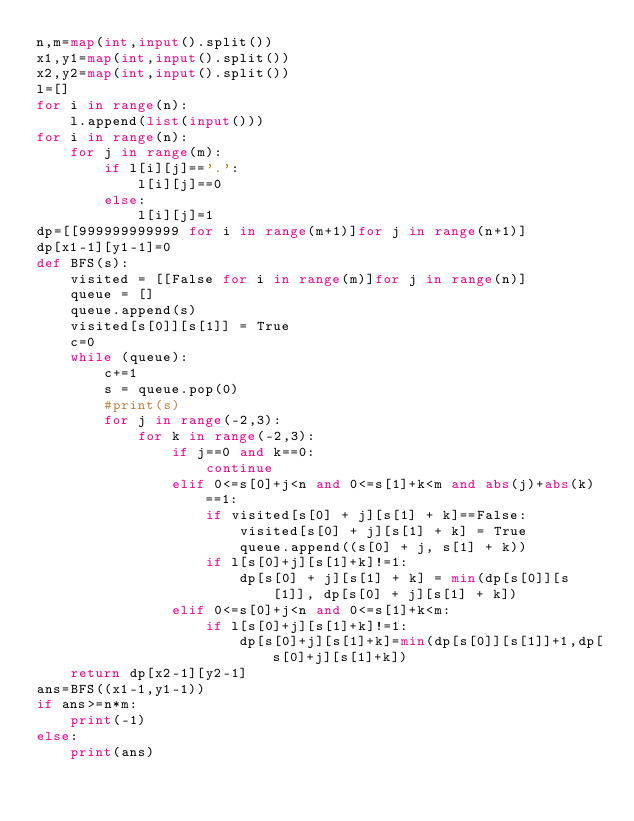Convert code to text. <code><loc_0><loc_0><loc_500><loc_500><_Python_>n,m=map(int,input().split())
x1,y1=map(int,input().split())
x2,y2=map(int,input().split())
l=[]
for i in range(n):
    l.append(list(input()))
for i in range(n):
    for j in range(m):
        if l[i][j]=='.':
            l[i][j]==0
        else:
            l[i][j]=1
dp=[[999999999999 for i in range(m+1)]for j in range(n+1)]
dp[x1-1][y1-1]=0
def BFS(s):
    visited = [[False for i in range(m)]for j in range(n)]
    queue = []
    queue.append(s)
    visited[s[0]][s[1]] = True
    c=0
    while (queue):
        c+=1
        s = queue.pop(0)
        #print(s)
        for j in range(-2,3):
            for k in range(-2,3):
                if j==0 and k==0:
                    continue
                elif 0<=s[0]+j<n and 0<=s[1]+k<m and abs(j)+abs(k)==1:
                    if visited[s[0] + j][s[1] + k]==False:
                        visited[s[0] + j][s[1] + k] = True
                        queue.append((s[0] + j, s[1] + k))
                    if l[s[0]+j][s[1]+k]!=1:
                        dp[s[0] + j][s[1] + k] = min(dp[s[0]][s[1]], dp[s[0] + j][s[1] + k])
                elif 0<=s[0]+j<n and 0<=s[1]+k<m:
                    if l[s[0]+j][s[1]+k]!=1:
                        dp[s[0]+j][s[1]+k]=min(dp[s[0]][s[1]]+1,dp[s[0]+j][s[1]+k])
    return dp[x2-1][y2-1]
ans=BFS((x1-1,y1-1))
if ans>=n*m:
    print(-1)
else:
    print(ans)</code> 